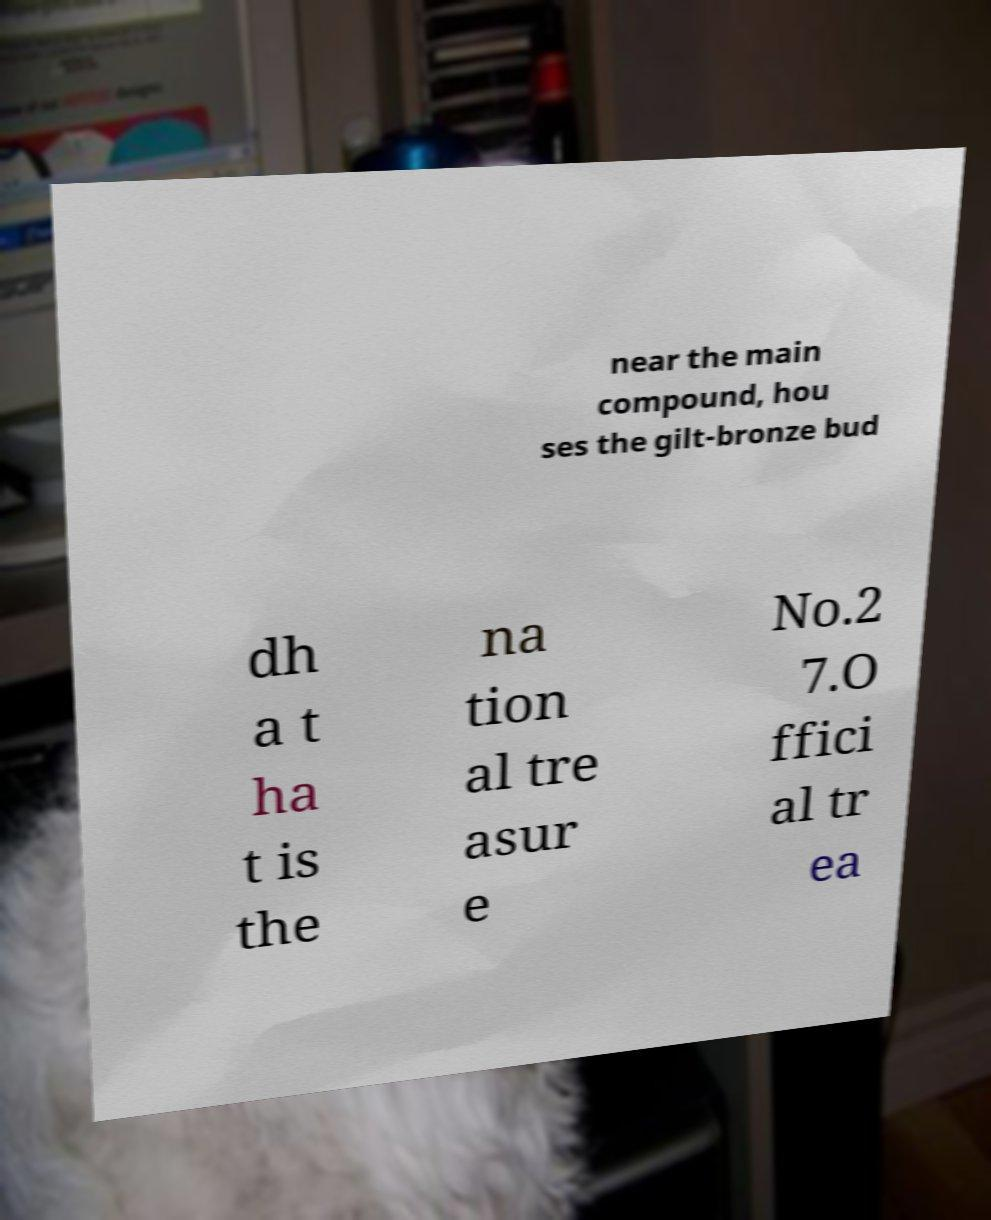Could you assist in decoding the text presented in this image and type it out clearly? near the main compound, hou ses the gilt-bronze bud dh a t ha t is the na tion al tre asur e No.2 7.O ffici al tr ea 